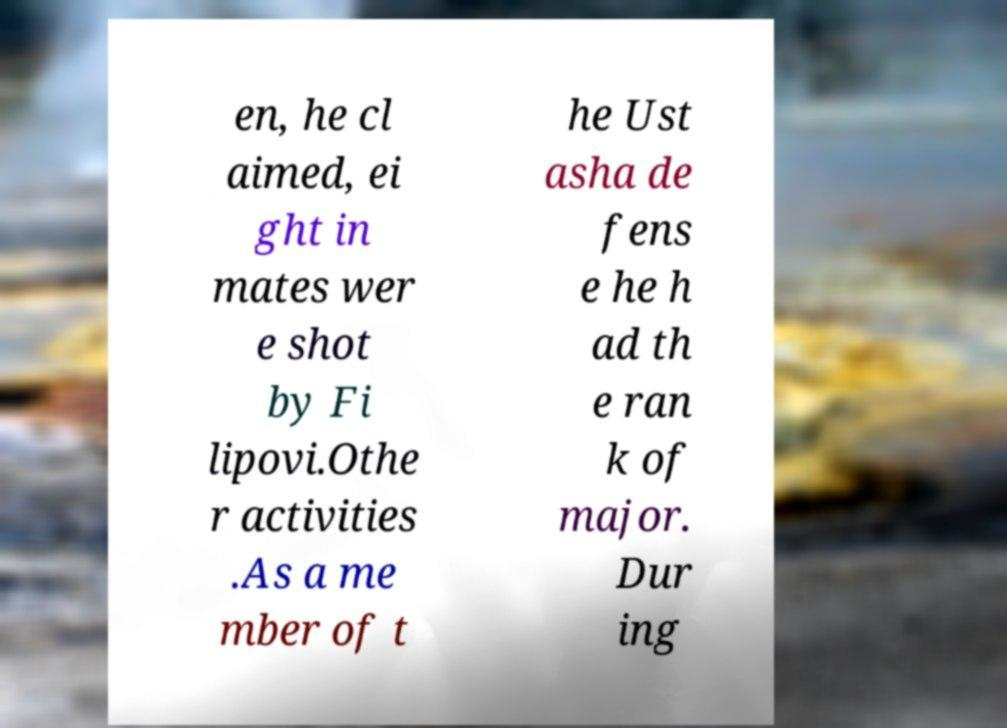Could you extract and type out the text from this image? en, he cl aimed, ei ght in mates wer e shot by Fi lipovi.Othe r activities .As a me mber of t he Ust asha de fens e he h ad th e ran k of major. Dur ing 